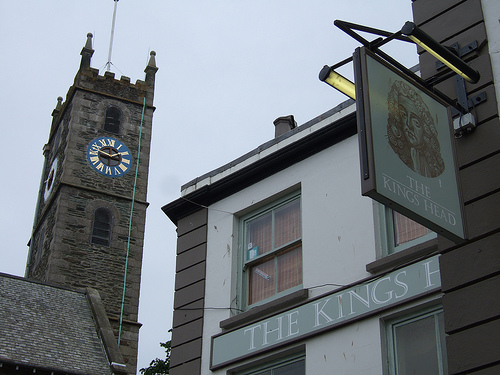What is on the sign on the front of the building? The sign on the front of the building reads 'The King's Head,' likely denoting the name of the pub located within. 